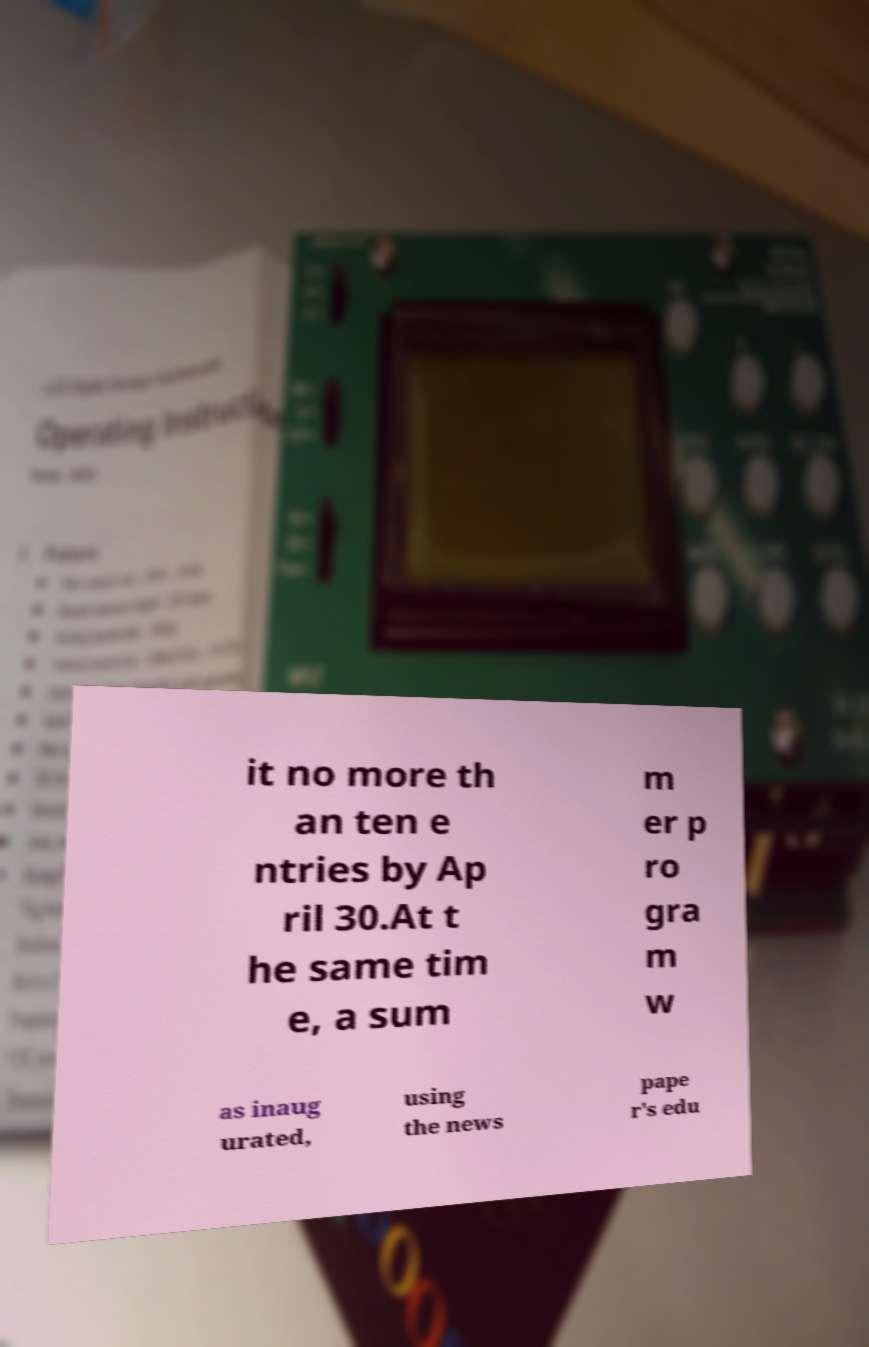Please identify and transcribe the text found in this image. it no more th an ten e ntries by Ap ril 30.At t he same tim e, a sum m er p ro gra m w as inaug urated, using the news pape r's edu 